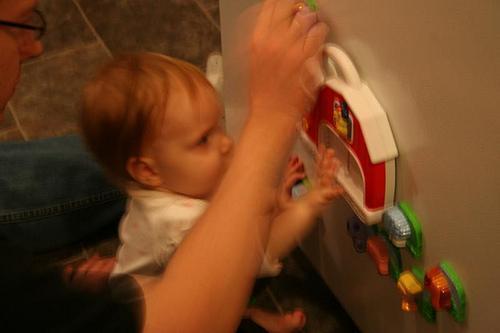What are the two using to play?
From the following four choices, select the correct answer to address the question.
Options: Screen, poster, dresser, refrigerator. Refrigerator. 